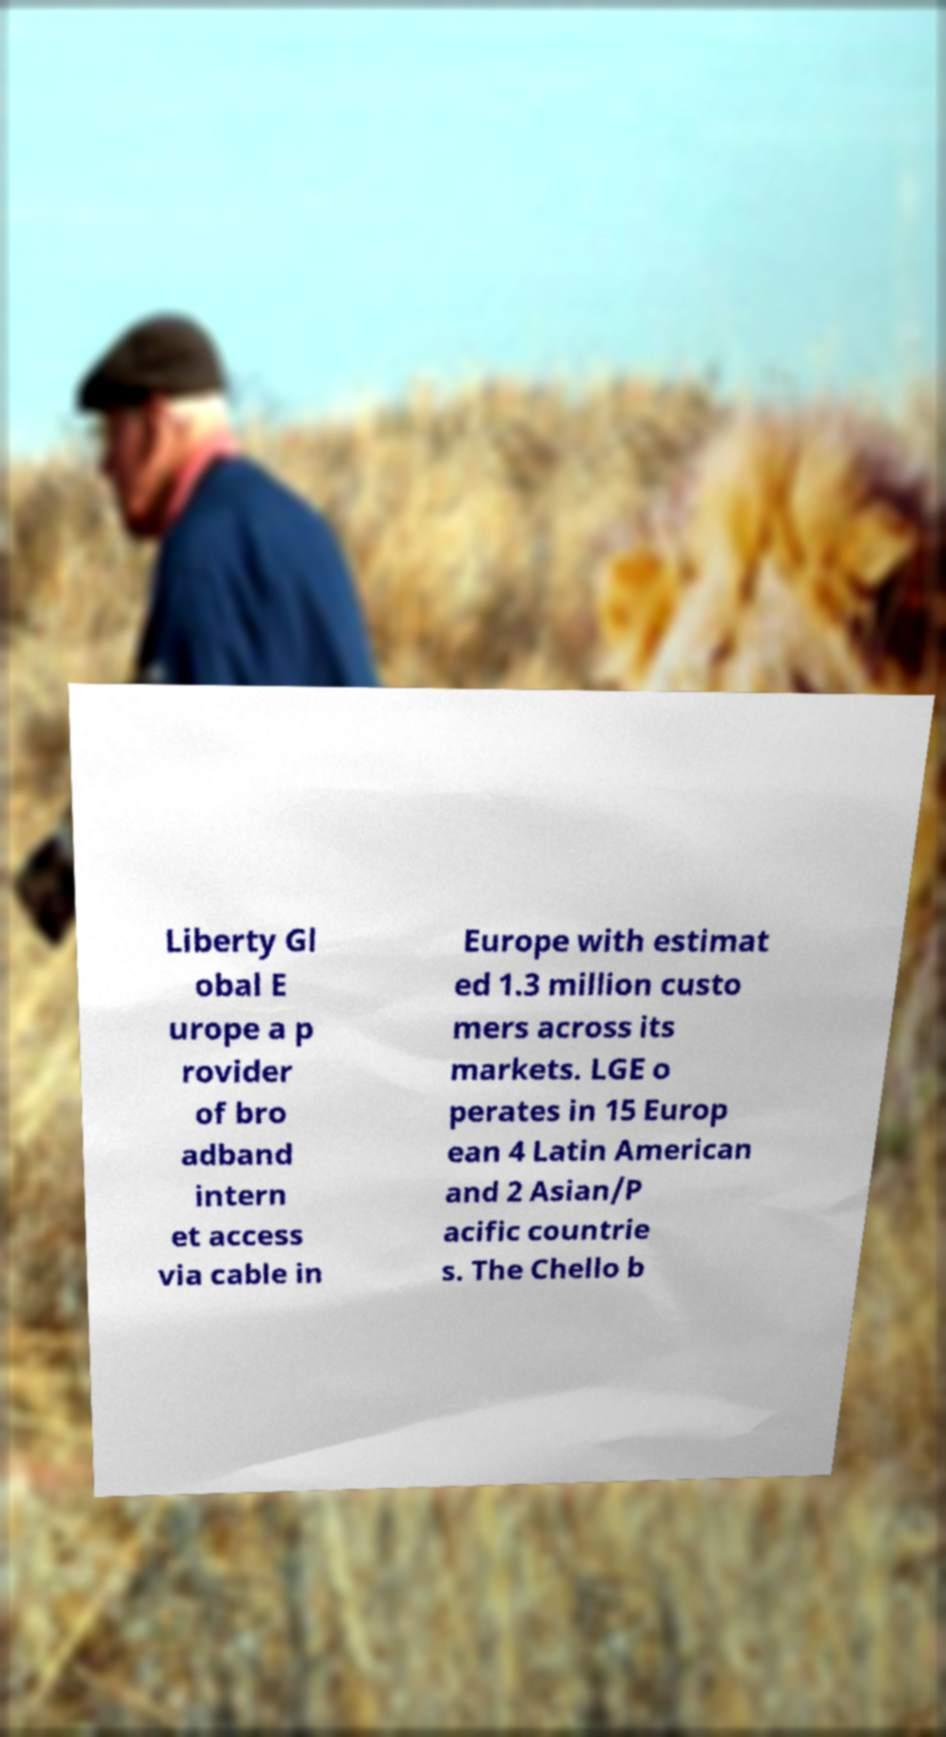I need the written content from this picture converted into text. Can you do that? Liberty Gl obal E urope a p rovider of bro adband intern et access via cable in Europe with estimat ed 1.3 million custo mers across its markets. LGE o perates in 15 Europ ean 4 Latin American and 2 Asian/P acific countrie s. The Chello b 